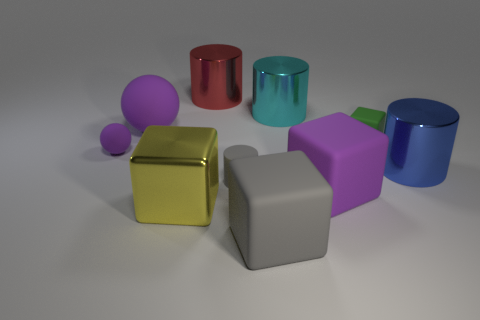Subtract 1 cylinders. How many cylinders are left? 3 Subtract all brown cylinders. Subtract all yellow balls. How many cylinders are left? 4 Subtract all cylinders. How many objects are left? 6 Add 6 small purple balls. How many small purple balls exist? 7 Subtract 0 red cubes. How many objects are left? 10 Subtract all big blue objects. Subtract all large brown objects. How many objects are left? 9 Add 2 cyan metallic cylinders. How many cyan metallic cylinders are left? 3 